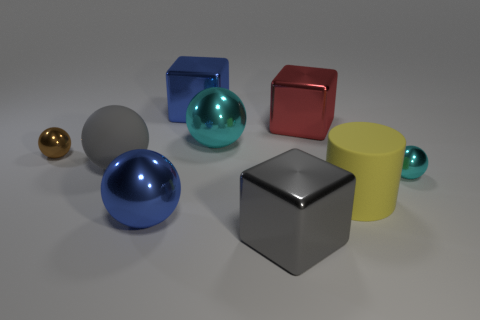There is a red cube that is the same size as the cylinder; what material is it?
Your answer should be compact. Metal. How many tiny things are on the left side of the cyan thing that is on the left side of the cyan ball to the right of the red metal block?
Your answer should be very brief. 1. There is a shiny thing right of the large yellow object; does it have the same color as the large metal block that is behind the red shiny block?
Your answer should be very brief. No. The object that is in front of the brown metallic object and to the left of the big blue shiny ball is what color?
Your answer should be very brief. Gray. How many yellow rubber cylinders are the same size as the yellow thing?
Ensure brevity in your answer.  0. What shape is the big blue object that is behind the large rubber thing that is on the right side of the big gray sphere?
Your answer should be compact. Cube. What shape is the large blue thing in front of the tiny shiny thing that is to the left of the big gray object that is behind the gray metallic cube?
Your response must be concise. Sphere. What number of large matte objects have the same shape as the small brown metal thing?
Keep it short and to the point. 1. What number of gray matte balls are in front of the large metallic cube in front of the small cyan thing?
Provide a short and direct response. 0. What number of rubber things are small yellow objects or gray balls?
Provide a short and direct response. 1. 